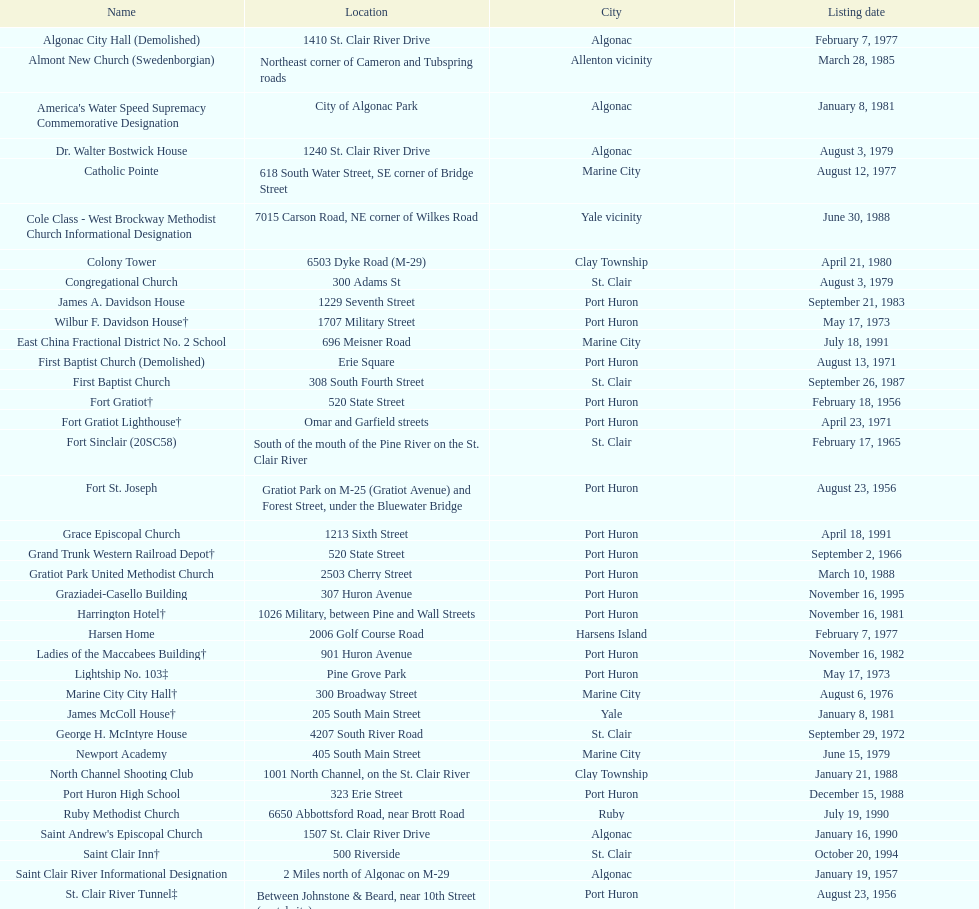What is the number of properties on the list that have been demolished? 2. 